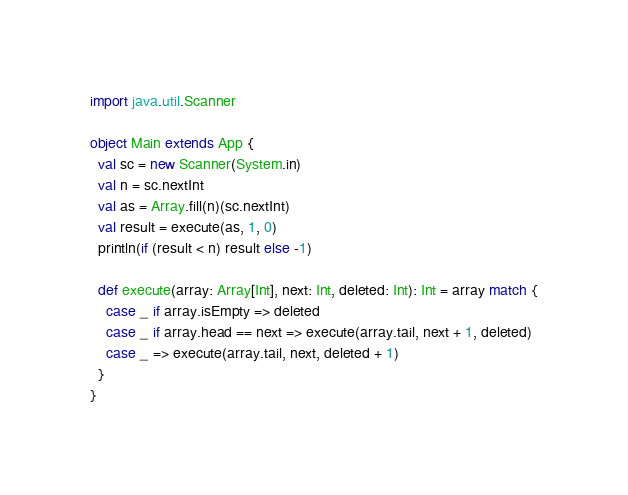<code> <loc_0><loc_0><loc_500><loc_500><_Scala_>import java.util.Scanner

object Main extends App {
  val sc = new Scanner(System.in)
  val n = sc.nextInt
  val as = Array.fill(n)(sc.nextInt)
  val result = execute(as, 1, 0)
  println(if (result < n) result else -1)

  def execute(array: Array[Int], next: Int, deleted: Int): Int = array match {
    case _ if array.isEmpty => deleted
    case _ if array.head == next => execute(array.tail, next + 1, deleted)
    case _ => execute(array.tail, next, deleted + 1)
  }
}
</code> 